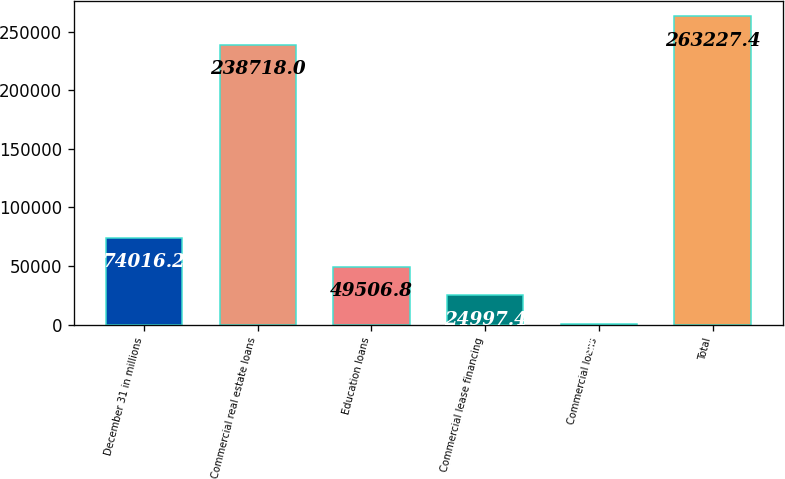<chart> <loc_0><loc_0><loc_500><loc_500><bar_chart><fcel>December 31 in millions<fcel>Commercial real estate loans<fcel>Education loans<fcel>Commercial lease financing<fcel>Commercial loans<fcel>Total<nl><fcel>74016.2<fcel>238718<fcel>49506.8<fcel>24997.4<fcel>488<fcel>263227<nl></chart> 